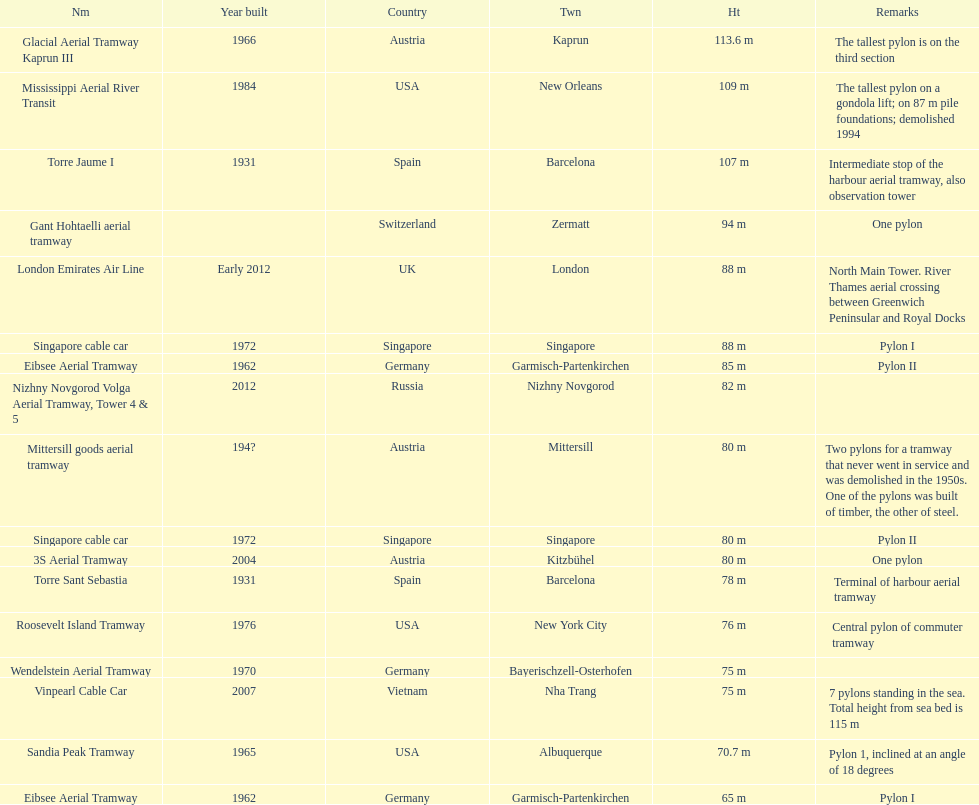Which pylon is the least tall? Eibsee Aerial Tramway. 